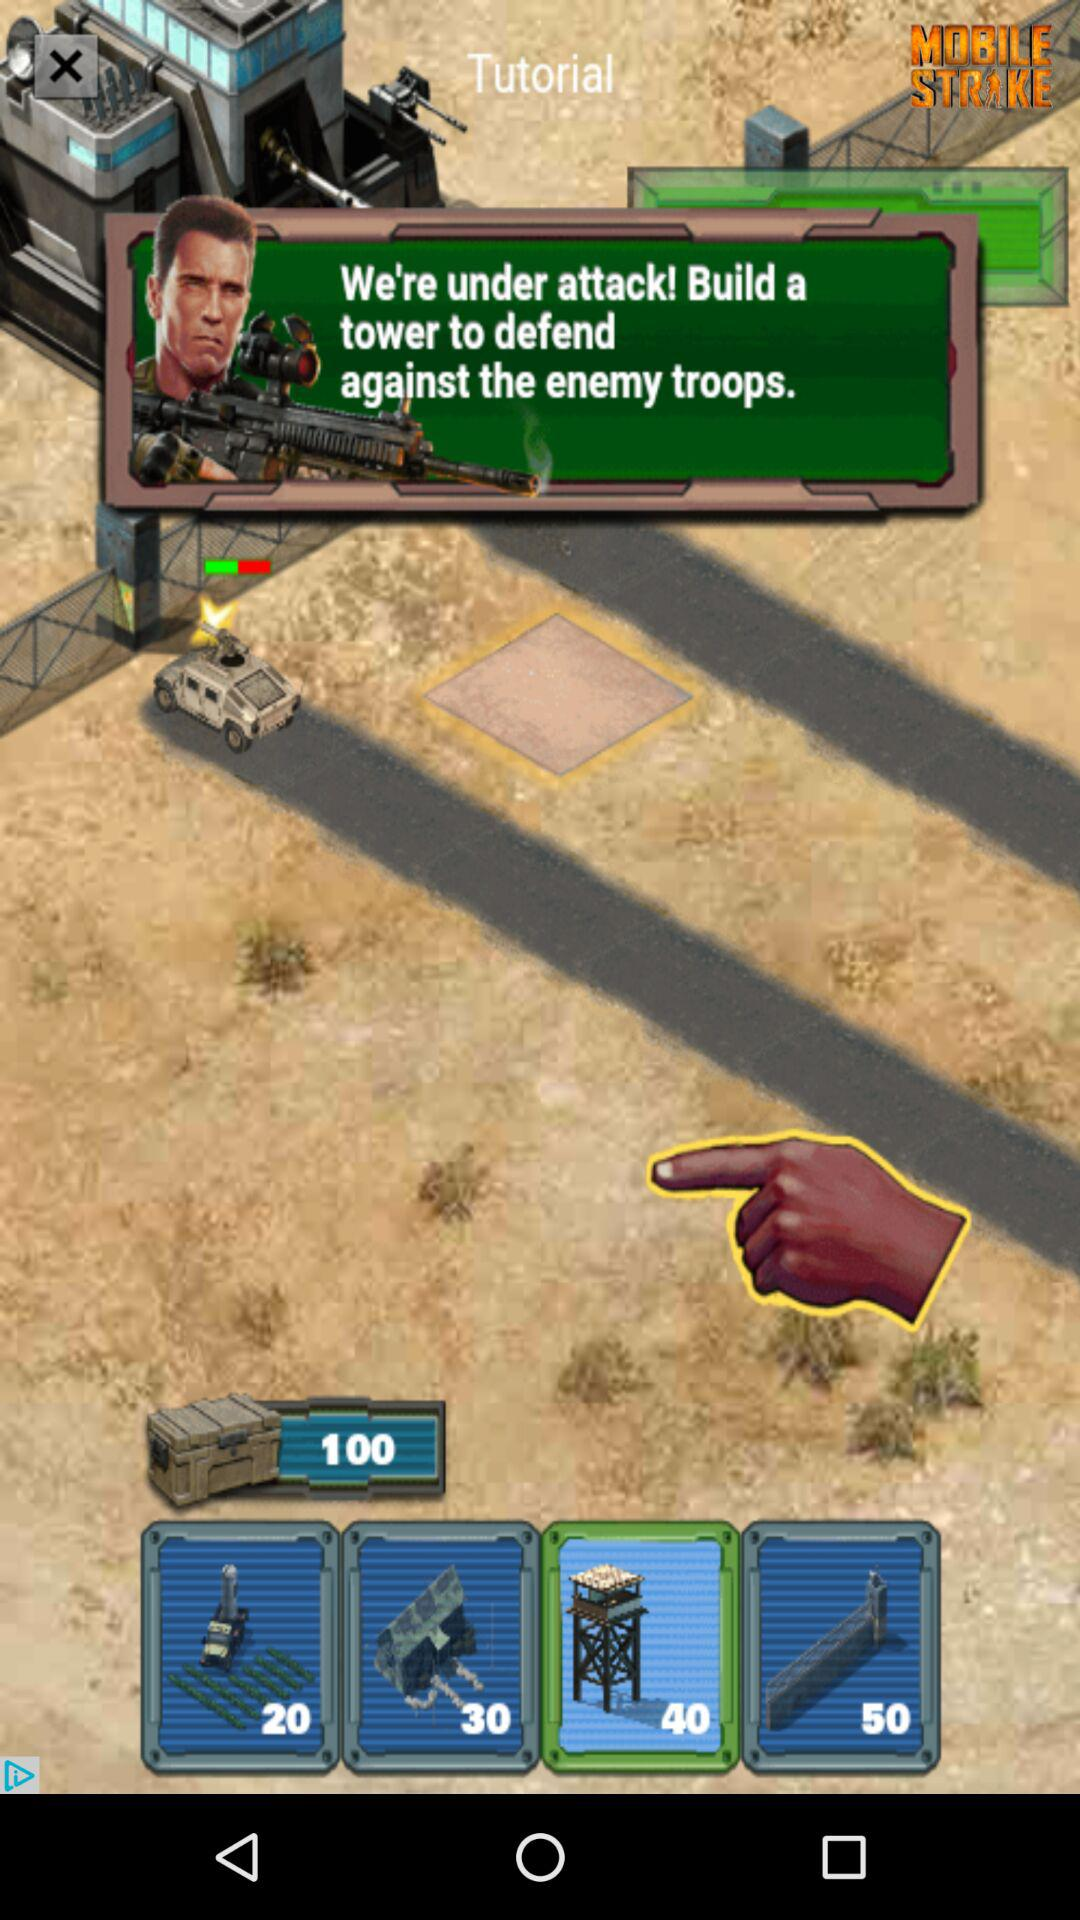How much more expensive is the 40 dollar tower than the 20 dollar tower?
Answer the question using a single word or phrase. 20 